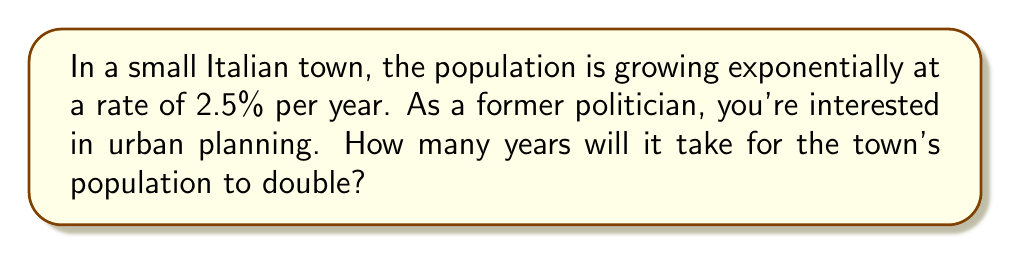Show me your answer to this math problem. Let's approach this step-by-step using the exponential growth model and logarithms:

1) The exponential growth model is given by:
   $$P(t) = P_0 e^{rt}$$
   where $P(t)$ is the population at time $t$, $P_0$ is the initial population, $r$ is the growth rate, and $t$ is time.

2) We want to find $t$ when the population doubles, so:
   $$2P_0 = P_0 e^{rt}$$

3) Dividing both sides by $P_0$:
   $$2 = e^{rt}$$

4) Taking the natural logarithm of both sides:
   $$\ln(2) = rt$$

5) Solving for $t$:
   $$t = \frac{\ln(2)}{r}$$

6) We're given $r = 2.5\% = 0.025$ per year.

7) Substituting this value:
   $$t = \frac{\ln(2)}{0.025} \approx 27.73$$

Therefore, it will take approximately 27.73 years for the population to double.
Answer: 27.73 years 